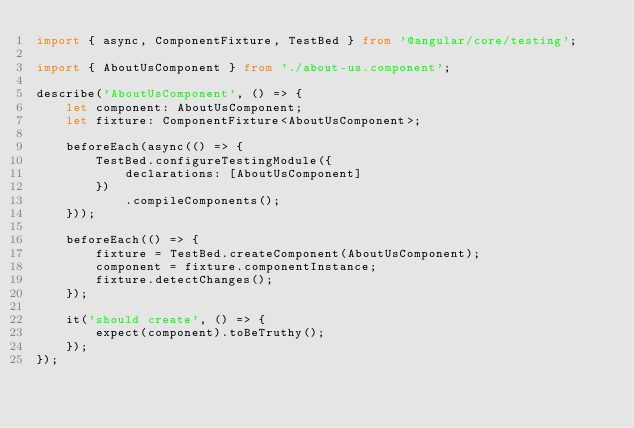Convert code to text. <code><loc_0><loc_0><loc_500><loc_500><_TypeScript_>import { async, ComponentFixture, TestBed } from '@angular/core/testing';

import { AboutUsComponent } from './about-us.component';

describe('AboutUsComponent', () => {
    let component: AboutUsComponent;
    let fixture: ComponentFixture<AboutUsComponent>;

    beforeEach(async(() => {
        TestBed.configureTestingModule({
            declarations: [AboutUsComponent]
        })
            .compileComponents();
    }));

    beforeEach(() => {
        fixture = TestBed.createComponent(AboutUsComponent);
        component = fixture.componentInstance;
        fixture.detectChanges();
    });

    it('should create', () => {
        expect(component).toBeTruthy();
    });
});
</code> 